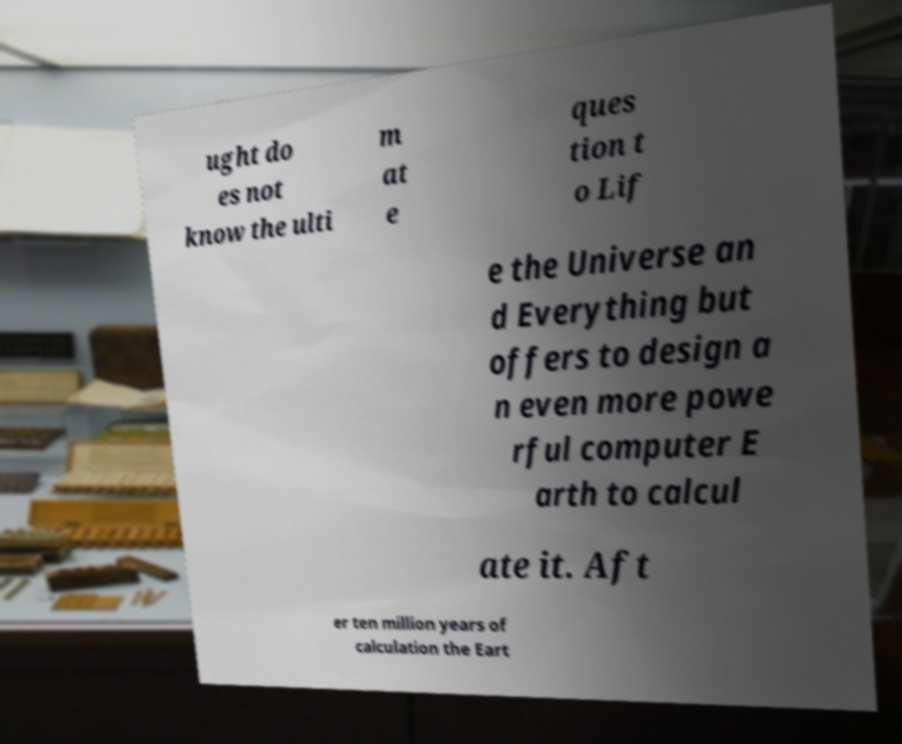Can you accurately transcribe the text from the provided image for me? ught do es not know the ulti m at e ques tion t o Lif e the Universe an d Everything but offers to design a n even more powe rful computer E arth to calcul ate it. Aft er ten million years of calculation the Eart 